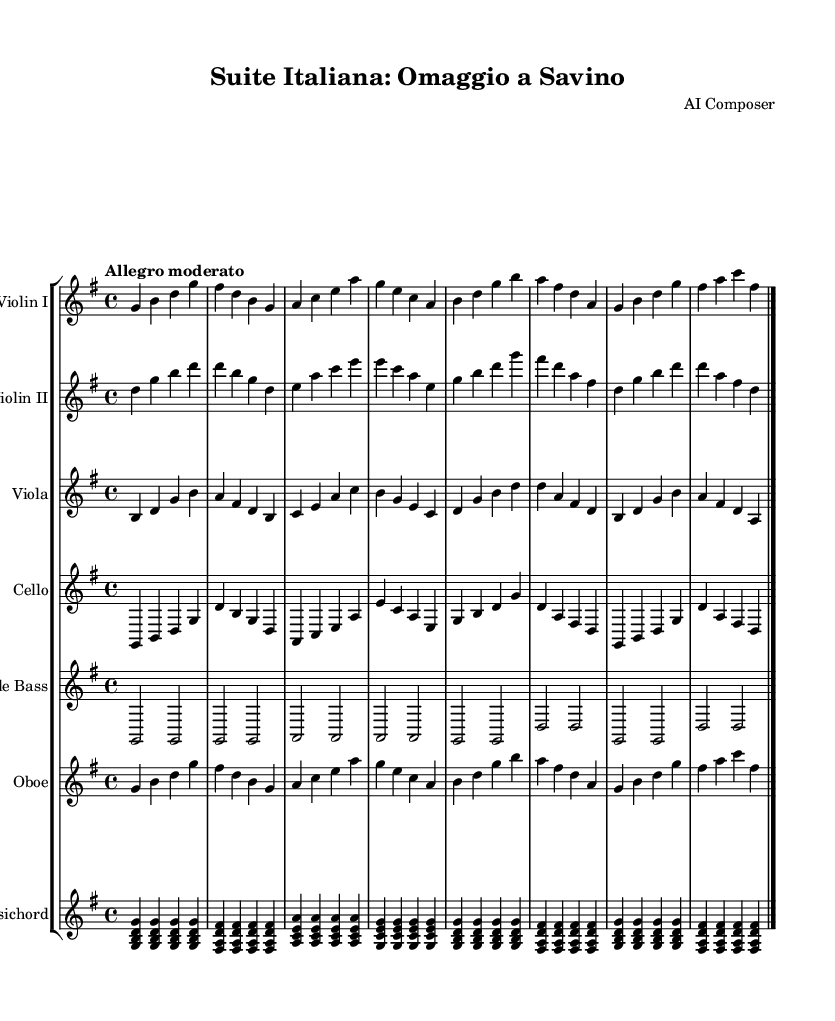What is the key signature of this music? The key signature is indicated at the beginning of the staff and shows one sharp, which corresponds to the key of G major.
Answer: G major What is the time signature of this piece? The time signature, found directly next to the key signature at the beginning of the score, is 4/4, indicating four beats per measure.
Answer: 4/4 What is the tempo marking for this composition? The tempo is specified at the beginning of the score with the marking "Allegro moderato," indicating a moderately fast pace.
Answer: Allegro moderato How many different string instruments are present in this orchestral suite? The score shows three different types of string instruments: Violin I, Violin II, and Viola, along with cello and double bass, totaling five string instruments.
Answer: Five Which two instruments have the same melodic line in the first eight bars? Observing the first eight bars, both the Violin I and the Oboe play identical melodic lines, demonstrating a unison texture in this section.
Answer: Violin I and Oboe What is the function of the harpsichord in this orchestral suite? The harpsichord is typically used to provide harmonic support and a continuo role in Baroque music, often filling in the chords based on the notation written in the score.
Answer: Continuo How does the composer incorporate folk elements in this suite? The use of recognizable melodic shapes typical of Italian folk music, intermingled with the Baroque style, suggests an integration of popular folk tunes into the structure of the suite.
Answer: Popular folk tunes 